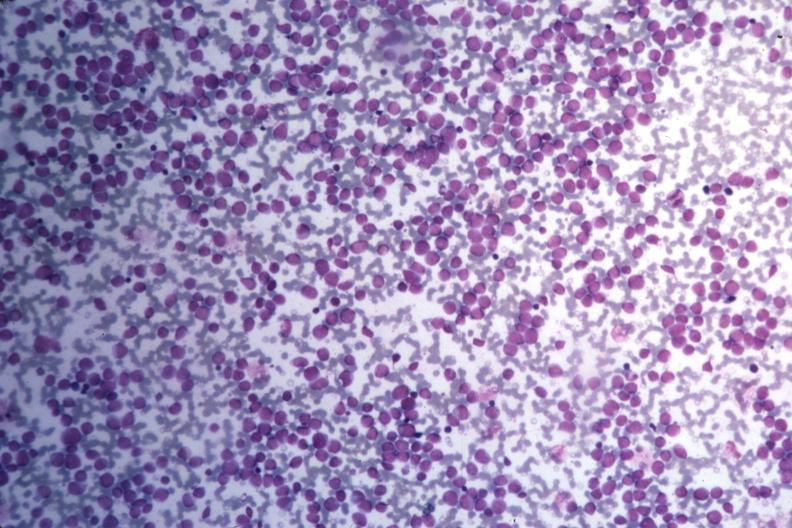does this image show med wrights stain many pleomorphic blast cells readily seen?
Answer the question using a single word or phrase. Yes 